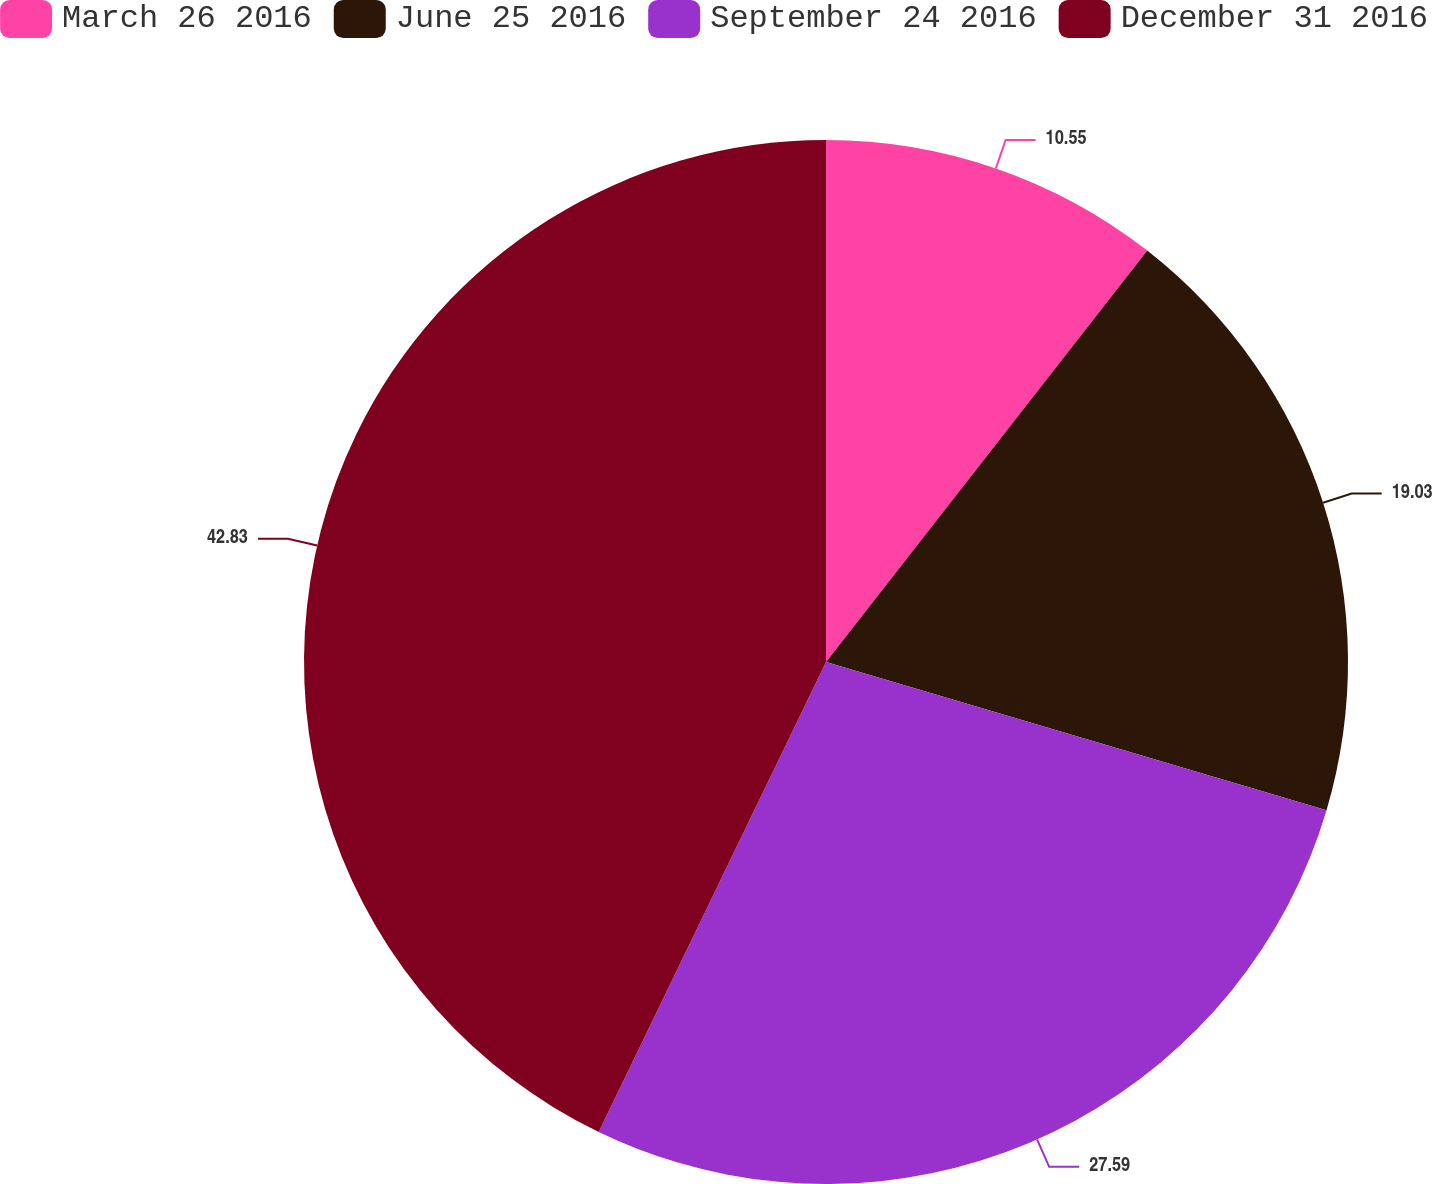<chart> <loc_0><loc_0><loc_500><loc_500><pie_chart><fcel>March 26 2016<fcel>June 25 2016<fcel>September 24 2016<fcel>December 31 2016<nl><fcel>10.55%<fcel>19.03%<fcel>27.59%<fcel>42.83%<nl></chart> 